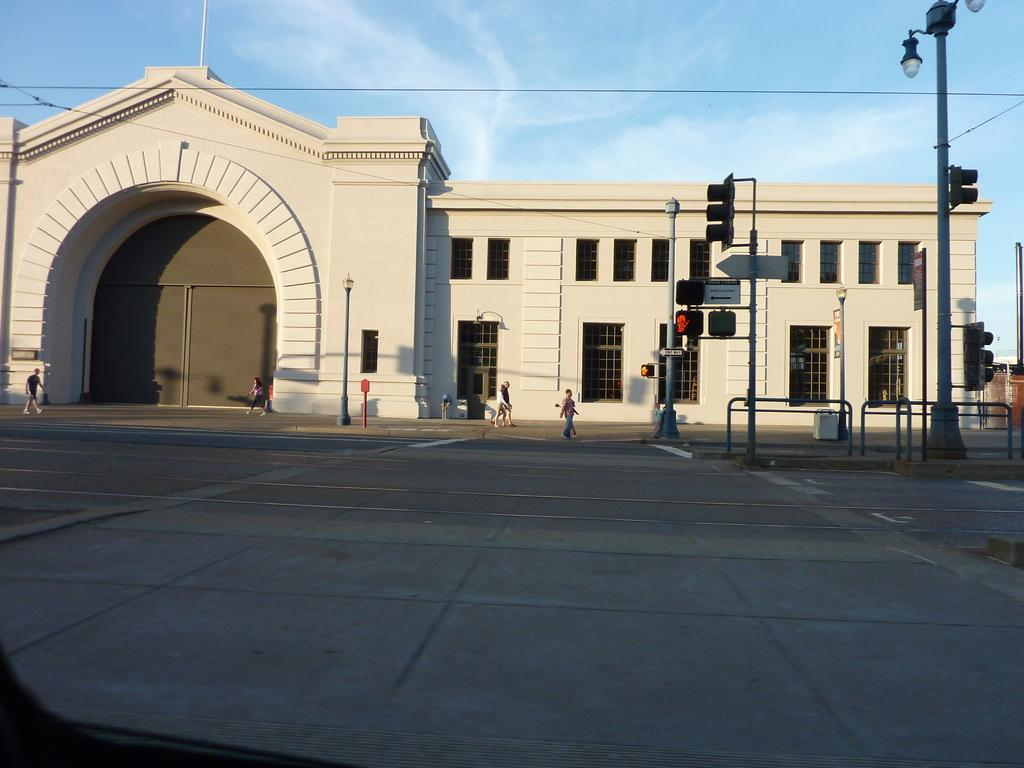What type of structure is present in the image? There is a building in the image. What is happening on the road in the image? There are people walking on the road in the image. What helps regulate traffic in the image? Signal lights are visible in the image. What type of curtain can be seen hanging in the building in the image? There is no curtain visible in the image; only the building, people walking on the road, and signal lights are present. 